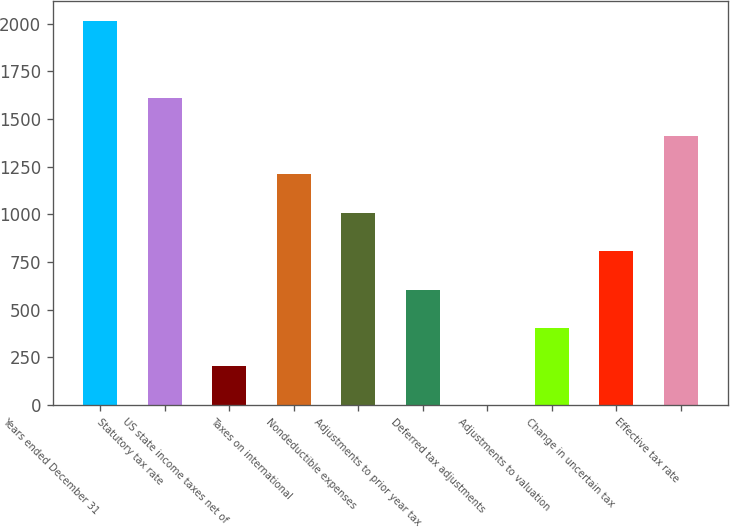Convert chart to OTSL. <chart><loc_0><loc_0><loc_500><loc_500><bar_chart><fcel>Years ended December 31<fcel>Statutory tax rate<fcel>US state income taxes net of<fcel>Taxes on international<fcel>Nondeductible expenses<fcel>Adjustments to prior year tax<fcel>Deferred tax adjustments<fcel>Adjustments to valuation<fcel>Change in uncertain tax<fcel>Effective tax rate<nl><fcel>2015<fcel>1612.02<fcel>201.59<fcel>1209.04<fcel>1007.55<fcel>604.57<fcel>0.1<fcel>403.08<fcel>806.06<fcel>1410.53<nl></chart> 